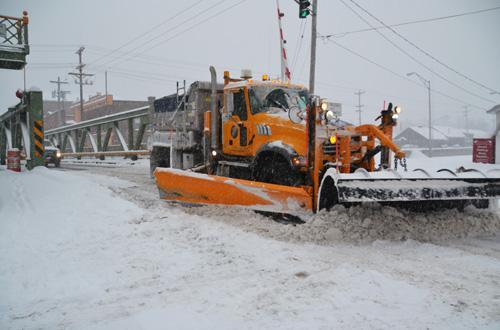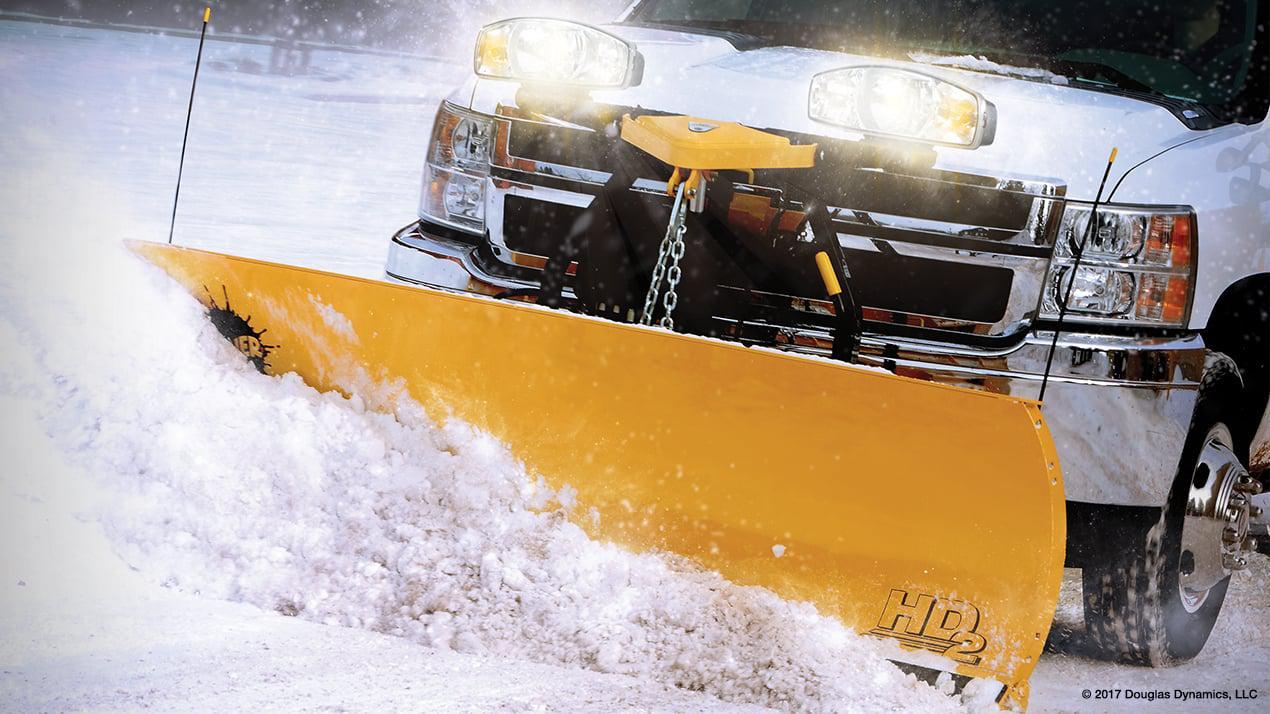The first image is the image on the left, the second image is the image on the right. Analyze the images presented: Is the assertion "A pickup truck with a yellow bulldozer front attachment is pushing a pile of snow." valid? Answer yes or no. Yes. 